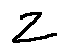<formula> <loc_0><loc_0><loc_500><loc_500>z</formula> 